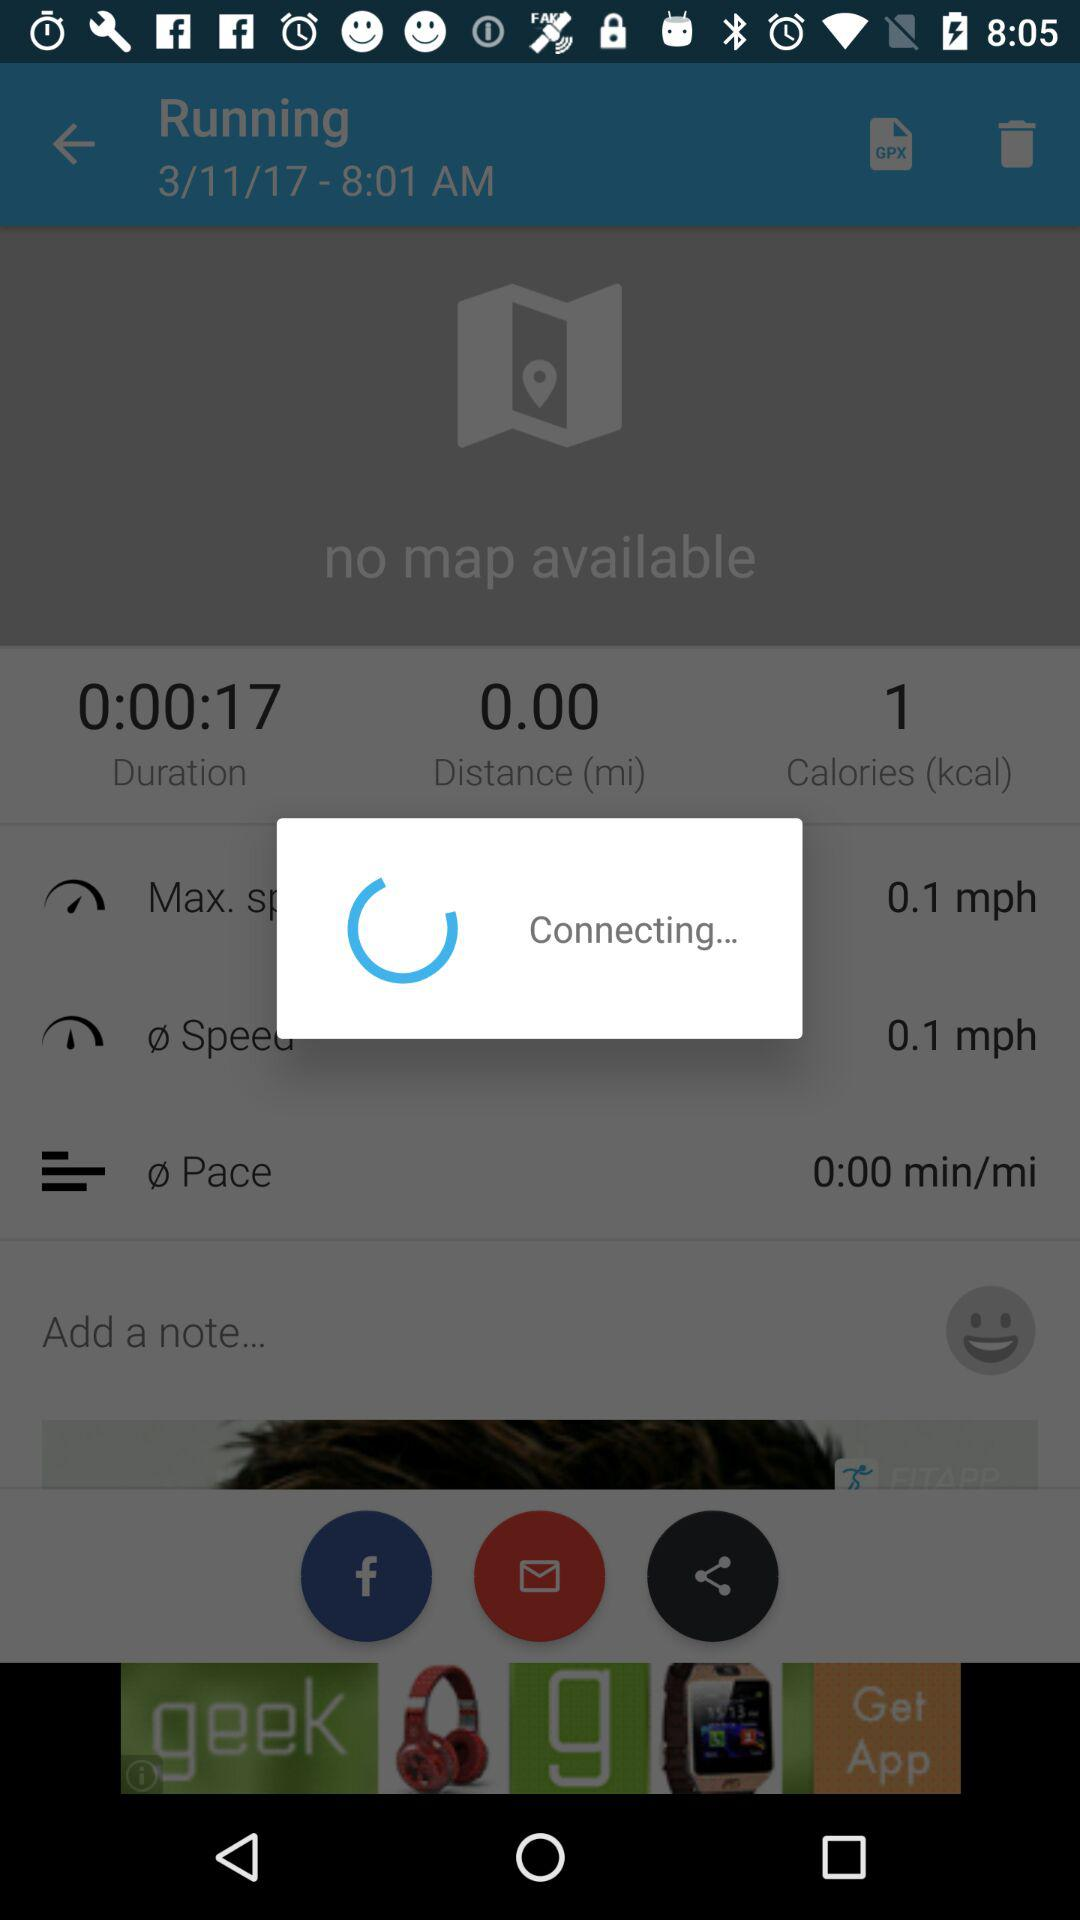How many calories are there? There is 1 calorie. 